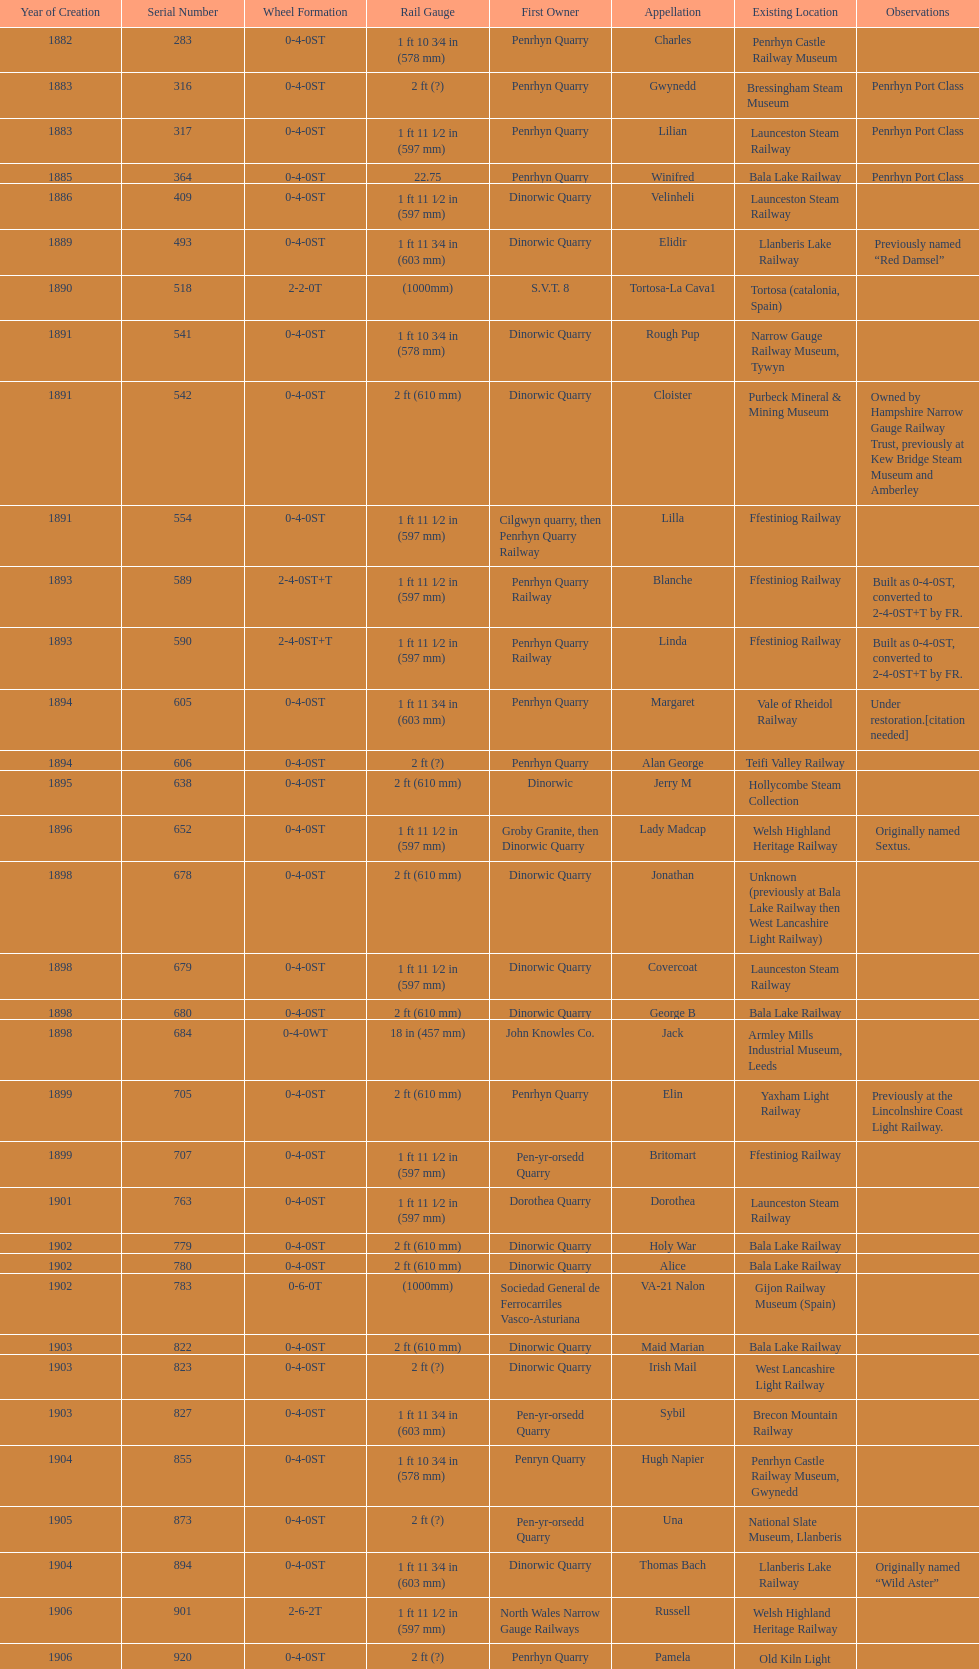Parse the full table. {'header': ['Year of Creation', 'Serial Number', 'Wheel Formation', 'Rail Gauge', 'First Owner', 'Appellation', 'Existing Location', 'Observations'], 'rows': [['1882', '283', '0-4-0ST', '1\xa0ft 10\xa03⁄4\xa0in (578\xa0mm)', 'Penrhyn Quarry', 'Charles', 'Penrhyn Castle Railway Museum', ''], ['1883', '316', '0-4-0ST', '2\xa0ft (?)', 'Penrhyn Quarry', 'Gwynedd', 'Bressingham Steam Museum', 'Penrhyn Port Class'], ['1883', '317', '0-4-0ST', '1\xa0ft 11\xa01⁄2\xa0in (597\xa0mm)', 'Penrhyn Quarry', 'Lilian', 'Launceston Steam Railway', 'Penrhyn Port Class'], ['1885', '364', '0-4-0ST', '22.75', 'Penrhyn Quarry', 'Winifred', 'Bala Lake Railway', 'Penrhyn Port Class'], ['1886', '409', '0-4-0ST', '1\xa0ft 11\xa01⁄2\xa0in (597\xa0mm)', 'Dinorwic Quarry', 'Velinheli', 'Launceston Steam Railway', ''], ['1889', '493', '0-4-0ST', '1\xa0ft 11\xa03⁄4\xa0in (603\xa0mm)', 'Dinorwic Quarry', 'Elidir', 'Llanberis Lake Railway', 'Previously named “Red Damsel”'], ['1890', '518', '2-2-0T', '(1000mm)', 'S.V.T. 8', 'Tortosa-La Cava1', 'Tortosa (catalonia, Spain)', ''], ['1891', '541', '0-4-0ST', '1\xa0ft 10\xa03⁄4\xa0in (578\xa0mm)', 'Dinorwic Quarry', 'Rough Pup', 'Narrow Gauge Railway Museum, Tywyn', ''], ['1891', '542', '0-4-0ST', '2\xa0ft (610\xa0mm)', 'Dinorwic Quarry', 'Cloister', 'Purbeck Mineral & Mining Museum', 'Owned by Hampshire Narrow Gauge Railway Trust, previously at Kew Bridge Steam Museum and Amberley'], ['1891', '554', '0-4-0ST', '1\xa0ft 11\xa01⁄2\xa0in (597\xa0mm)', 'Cilgwyn quarry, then Penrhyn Quarry Railway', 'Lilla', 'Ffestiniog Railway', ''], ['1893', '589', '2-4-0ST+T', '1\xa0ft 11\xa01⁄2\xa0in (597\xa0mm)', 'Penrhyn Quarry Railway', 'Blanche', 'Ffestiniog Railway', 'Built as 0-4-0ST, converted to 2-4-0ST+T by FR.'], ['1893', '590', '2-4-0ST+T', '1\xa0ft 11\xa01⁄2\xa0in (597\xa0mm)', 'Penrhyn Quarry Railway', 'Linda', 'Ffestiniog Railway', 'Built as 0-4-0ST, converted to 2-4-0ST+T by FR.'], ['1894', '605', '0-4-0ST', '1\xa0ft 11\xa03⁄4\xa0in (603\xa0mm)', 'Penrhyn Quarry', 'Margaret', 'Vale of Rheidol Railway', 'Under restoration.[citation needed]'], ['1894', '606', '0-4-0ST', '2\xa0ft (?)', 'Penrhyn Quarry', 'Alan George', 'Teifi Valley Railway', ''], ['1895', '638', '0-4-0ST', '2\xa0ft (610\xa0mm)', 'Dinorwic', 'Jerry M', 'Hollycombe Steam Collection', ''], ['1896', '652', '0-4-0ST', '1\xa0ft 11\xa01⁄2\xa0in (597\xa0mm)', 'Groby Granite, then Dinorwic Quarry', 'Lady Madcap', 'Welsh Highland Heritage Railway', 'Originally named Sextus.'], ['1898', '678', '0-4-0ST', '2\xa0ft (610\xa0mm)', 'Dinorwic Quarry', 'Jonathan', 'Unknown (previously at Bala Lake Railway then West Lancashire Light Railway)', ''], ['1898', '679', '0-4-0ST', '1\xa0ft 11\xa01⁄2\xa0in (597\xa0mm)', 'Dinorwic Quarry', 'Covercoat', 'Launceston Steam Railway', ''], ['1898', '680', '0-4-0ST', '2\xa0ft (610\xa0mm)', 'Dinorwic Quarry', 'George B', 'Bala Lake Railway', ''], ['1898', '684', '0-4-0WT', '18\xa0in (457\xa0mm)', 'John Knowles Co.', 'Jack', 'Armley Mills Industrial Museum, Leeds', ''], ['1899', '705', '0-4-0ST', '2\xa0ft (610\xa0mm)', 'Penrhyn Quarry', 'Elin', 'Yaxham Light Railway', 'Previously at the Lincolnshire Coast Light Railway.'], ['1899', '707', '0-4-0ST', '1\xa0ft 11\xa01⁄2\xa0in (597\xa0mm)', 'Pen-yr-orsedd Quarry', 'Britomart', 'Ffestiniog Railway', ''], ['1901', '763', '0-4-0ST', '1\xa0ft 11\xa01⁄2\xa0in (597\xa0mm)', 'Dorothea Quarry', 'Dorothea', 'Launceston Steam Railway', ''], ['1902', '779', '0-4-0ST', '2\xa0ft (610\xa0mm)', 'Dinorwic Quarry', 'Holy War', 'Bala Lake Railway', ''], ['1902', '780', '0-4-0ST', '2\xa0ft (610\xa0mm)', 'Dinorwic Quarry', 'Alice', 'Bala Lake Railway', ''], ['1902', '783', '0-6-0T', '(1000mm)', 'Sociedad General de Ferrocarriles Vasco-Asturiana', 'VA-21 Nalon', 'Gijon Railway Museum (Spain)', ''], ['1903', '822', '0-4-0ST', '2\xa0ft (610\xa0mm)', 'Dinorwic Quarry', 'Maid Marian', 'Bala Lake Railway', ''], ['1903', '823', '0-4-0ST', '2\xa0ft (?)', 'Dinorwic Quarry', 'Irish Mail', 'West Lancashire Light Railway', ''], ['1903', '827', '0-4-0ST', '1\xa0ft 11\xa03⁄4\xa0in (603\xa0mm)', 'Pen-yr-orsedd Quarry', 'Sybil', 'Brecon Mountain Railway', ''], ['1904', '855', '0-4-0ST', '1\xa0ft 10\xa03⁄4\xa0in (578\xa0mm)', 'Penryn Quarry', 'Hugh Napier', 'Penrhyn Castle Railway Museum, Gwynedd', ''], ['1905', '873', '0-4-0ST', '2\xa0ft (?)', 'Pen-yr-orsedd Quarry', 'Una', 'National Slate Museum, Llanberis', ''], ['1904', '894', '0-4-0ST', '1\xa0ft 11\xa03⁄4\xa0in (603\xa0mm)', 'Dinorwic Quarry', 'Thomas Bach', 'Llanberis Lake Railway', 'Originally named “Wild Aster”'], ['1906', '901', '2-6-2T', '1\xa0ft 11\xa01⁄2\xa0in (597\xa0mm)', 'North Wales Narrow Gauge Railways', 'Russell', 'Welsh Highland Heritage Railway', ''], ['1906', '920', '0-4-0ST', '2\xa0ft (?)', 'Penrhyn Quarry', 'Pamela', 'Old Kiln Light Railway', ''], ['1909', '994', '0-4-0ST', '2\xa0ft (?)', 'Penrhyn Quarry', 'Bill Harvey', 'Bressingham Steam Museum', 'previously George Sholto'], ['1918', '1312', '4-6-0T', '1\xa0ft\xa011\xa01⁄2\xa0in (597\xa0mm)', 'British War Department\\nEFOP #203', '---', 'Pampas Safari, Gravataí, RS, Brazil', '[citation needed]'], ['1918\\nor\\n1921?', '1313', '0-6-2T', '3\xa0ft\xa03\xa03⁄8\xa0in (1,000\xa0mm)', 'British War Department\\nUsina Leão Utinga #1\\nUsina Laginha #1', '---', 'Usina Laginha, União dos Palmares, AL, Brazil', '[citation needed]'], ['1920', '1404', '0-4-0WT', '18\xa0in (457\xa0mm)', 'John Knowles Co.', 'Gwen', 'Richard Farmer current owner, Northridge, California, USA', ''], ['1922', '1429', '0-4-0ST', '2\xa0ft (610\xa0mm)', 'Dinorwic', 'Lady Joan', 'Bredgar and Wormshill Light Railway', ''], ['1922', '1430', '0-4-0ST', '1\xa0ft 11\xa03⁄4\xa0in (603\xa0mm)', 'Dinorwic Quarry', 'Dolbadarn', 'Llanberis Lake Railway', ''], ['1937', '1859', '0-4-2T', '2\xa0ft (?)', 'Umtwalumi Valley Estate, Natal', '16 Carlisle', 'South Tynedale Railway', ''], ['1940', '2075', '0-4-2T', '2\xa0ft (?)', 'Chaka’s Kraal Sugar Estates, Natal', 'Chaka’s Kraal No. 6', 'North Gloucestershire Railway', ''], ['1954', '3815', '2-6-2T', '2\xa0ft 6\xa0in (762\xa0mm)', 'Sierra Leone Government Railway', '14', 'Welshpool and Llanfair Light Railway', ''], ['1971', '3902', '0-4-2ST', '2\xa0ft (610\xa0mm)', 'Trangkil Sugar Mill, Indonesia', 'Trangkil No.4', 'Statfold Barn Railway', 'Converted from 750\xa0mm (2\xa0ft\xa05\xa01⁄2\xa0in) gauge. Last steam locomotive to be built by Hunslet, and the last industrial steam locomotive built in Britain.']]} What is the total number of preserved hunslet narrow gauge locomotives currently located in ffestiniog railway 554. 